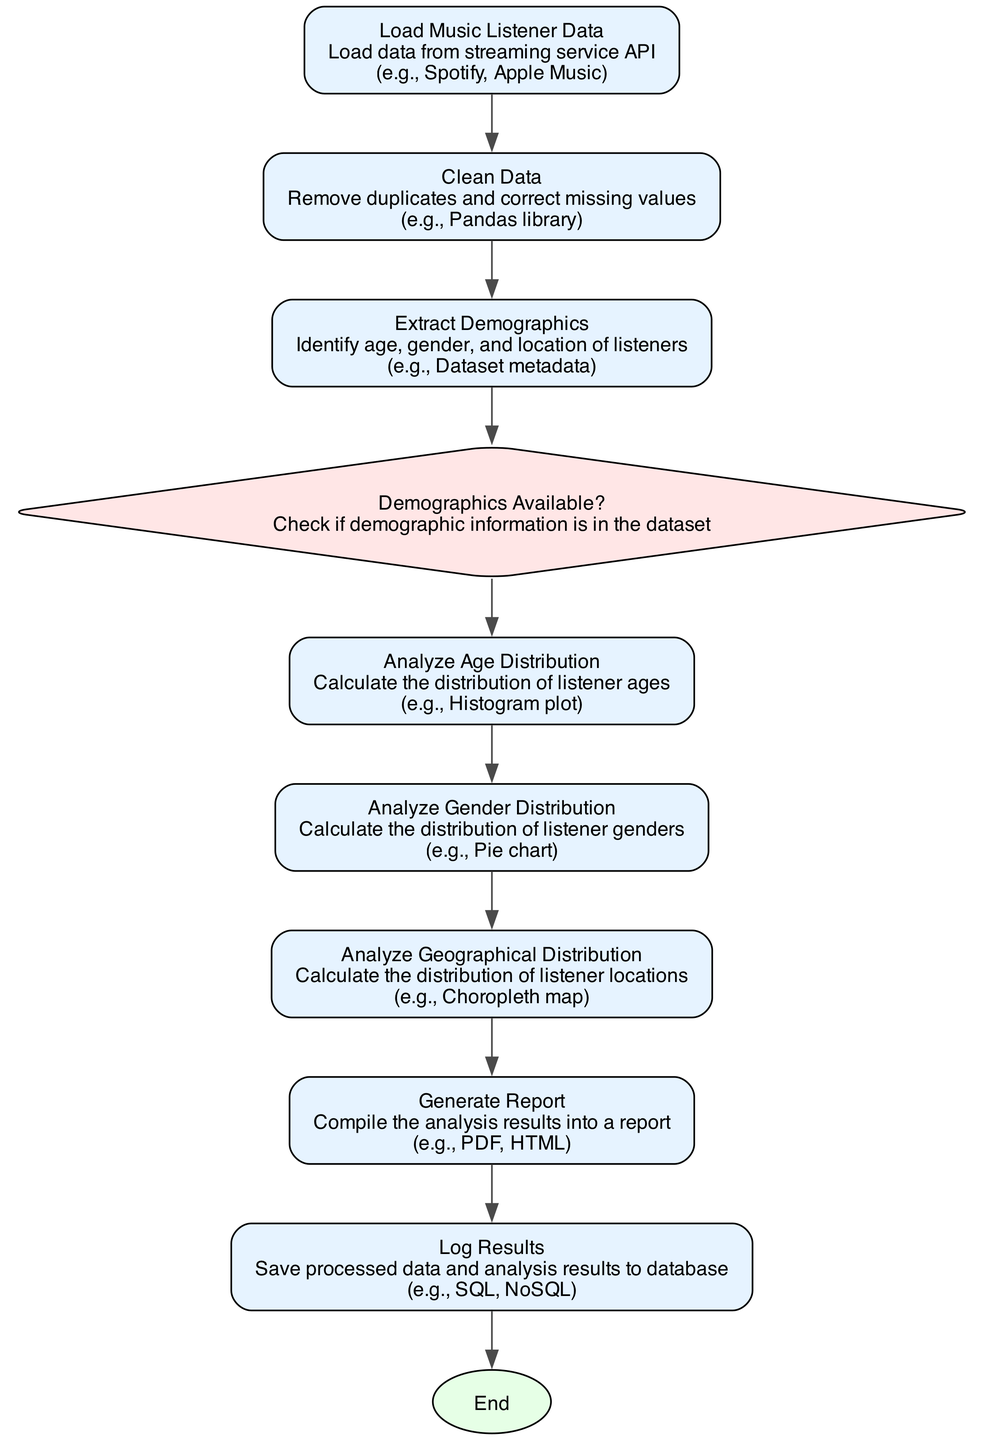What is the first process in the flowchart? The first process in the flowchart is "Load Music Listener Data". It is the first element listed in the provided data structure.
Answer: Load Music Listener Data How many decision nodes are there in the flowchart? There is one decision node in the flowchart, labeled "Demographics Available?". It is identified in the structure where 'decision' is indicated.
Answer: One What is the shape of the last node in the flowchart? The last node is labeled "End" and is represented as an ellipse according to the styles specified for terminator nodes in the diagram creation code.
Answer: Ellipse What process directly follows “Clean Data”? The process that directly follows "Clean Data" is "Extract Demographics". This can be traced by following the nodes in order as listed.
Answer: Extract Demographics If demographics are not available, what does the flowchart suggest? The flowchart doesn't include processes that proceed when demographics are not available; therefore, it indicates a halt or termination of the process.
Answer: End What type of diagram is this? This diagram is a flowchart, specifically designed to represent a data processing function in Python for analyzing listener demographics based on the provided descriptors.
Answer: Flowchart Which visualization technique is suggested for analyzing age distribution? The suggested visualization technique for analyzing age distribution is a histogram plot, as noted in the details for that process.
Answer: Histogram plot What is the final action taken in the flowchart? The final action taken in the flowchart is "Log Results", which indicates the saving of processed data and analysis outcomes. This can be determined as it is the last process before termination.
Answer: Log Results 